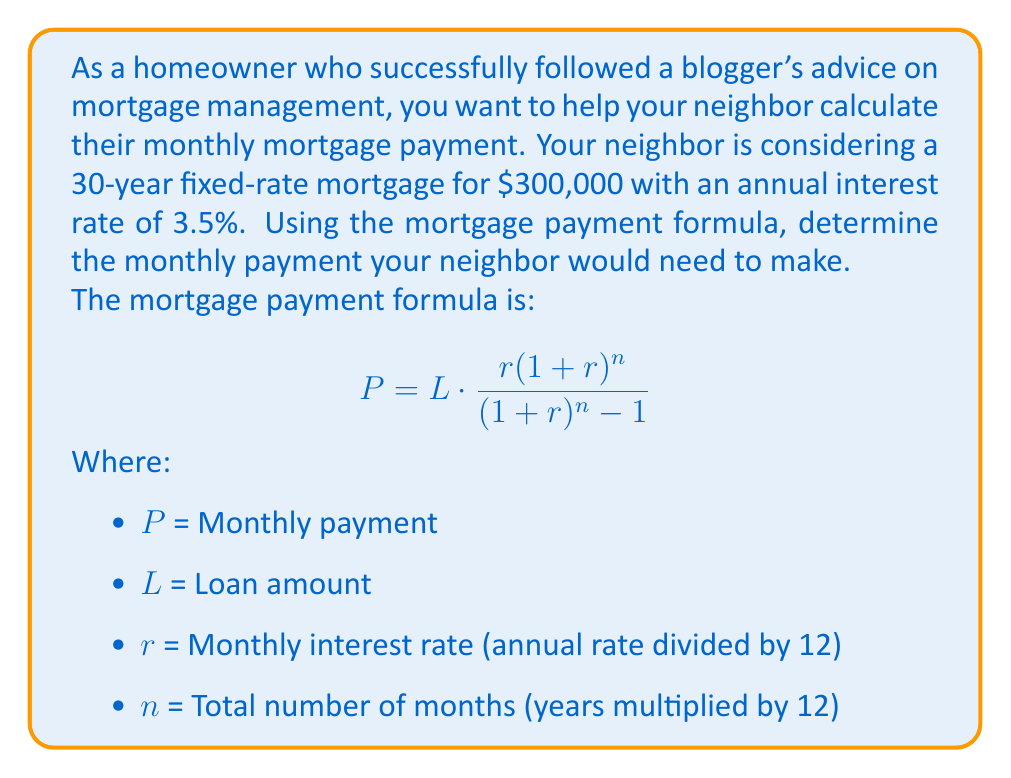Help me with this question. Let's break down the problem and solve it step by step:

1. Identify the given information:
   - Loan amount (L) = $300,000
   - Annual interest rate = 3.5% = 0.035
   - Loan term = 30 years

2. Calculate the monthly interest rate (r):
   $r = \frac{\text{Annual rate}}{12} = \frac{0.035}{12} = 0.002916667$

3. Calculate the total number of months (n):
   $n = 30 \text{ years} \times 12 \text{ months/year} = 360 \text{ months}$

4. Now, let's substitute these values into the mortgage payment formula:

   $$P = 300000 \cdot \frac{0.002916667(1+0.002916667)^{360}}{(1+0.002916667)^{360} - 1}$$

5. Use a calculator or spreadsheet to compute this complex expression:

   $$P = 300000 \cdot \frac{0.004491305}{0.648514348} = 300000 \cdot 0.006925503$$

6. Perform the final calculation:

   $$P = 2077.65$$

Therefore, the monthly mortgage payment would be $2,077.65.
Answer: $2,077.65 per month 